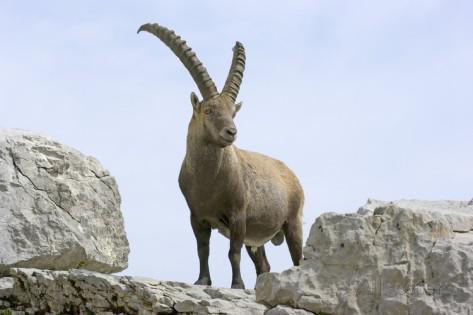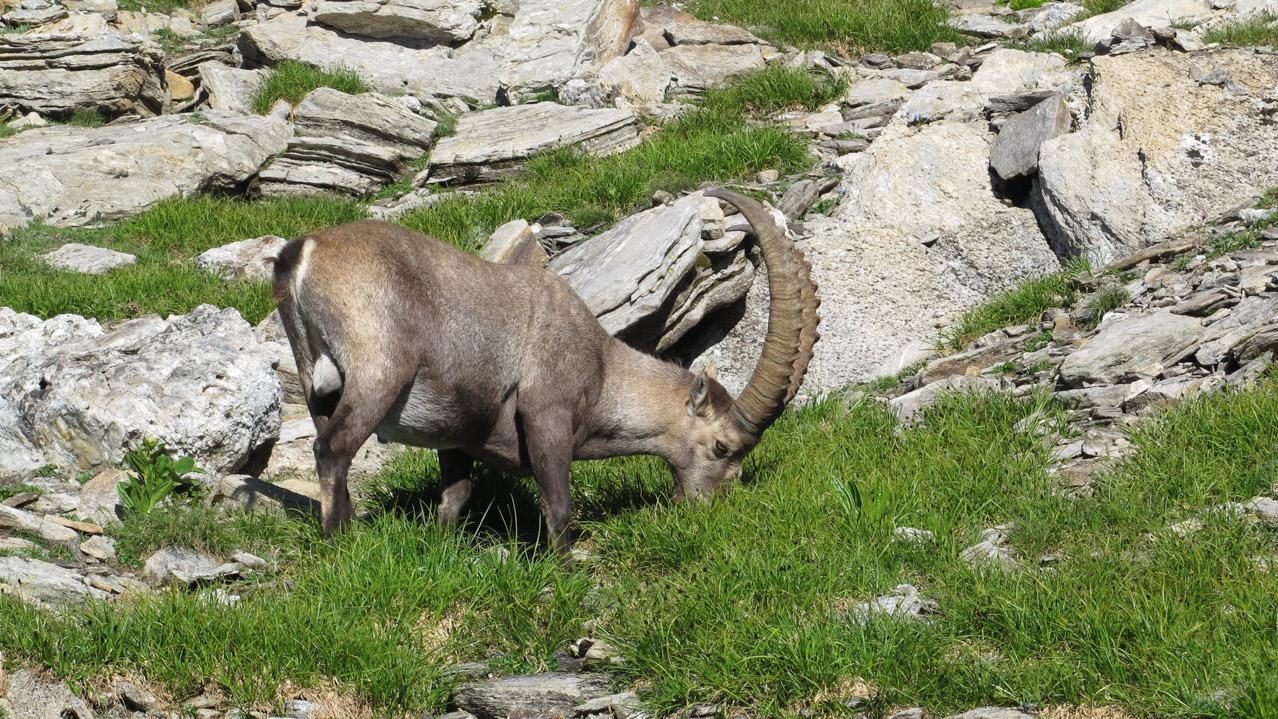The first image is the image on the left, the second image is the image on the right. For the images displayed, is the sentence "An image shows exactly one horned animal, which stands with body angled leftward and head angled rightward." factually correct? Answer yes or no. Yes. The first image is the image on the left, the second image is the image on the right. Examine the images to the left and right. Is the description "There are three antelopes in total." accurate? Answer yes or no. No. 